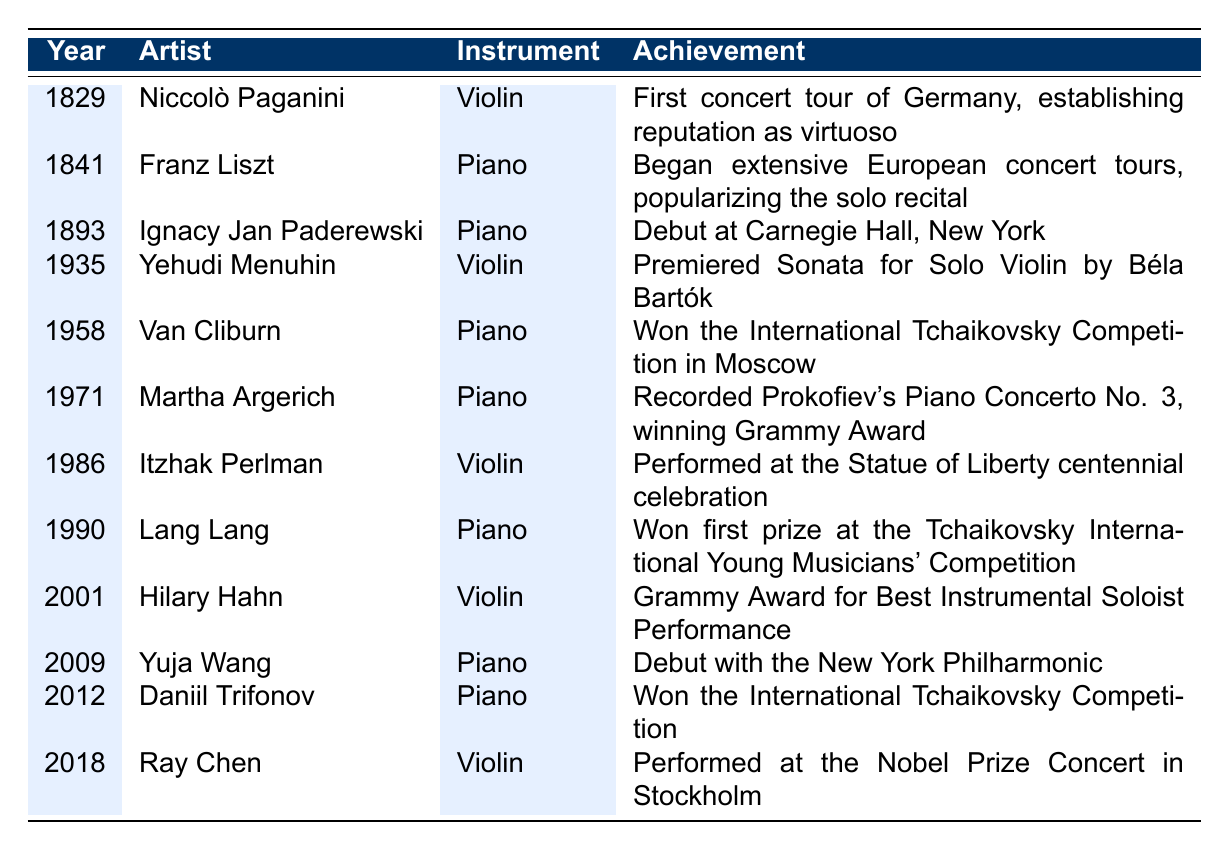What year did Van Cliburn win the International Tchaikovsky Competition? From the table, we can see that Van Cliburn achieved this in the year 1958.
Answer: 1958 Which pianist made his debut at Carnegie Hall in 1893? The table indicates that Ignacy Jan Paderewski made his debut at Carnegie Hall in the year 1893.
Answer: Ignacy Jan Paderewski True or False: Yehudi Menuhin performed a premiere in 1958. The table lists Yehudi Menuhin's notable achievement in 1935, indicating that the statement is false as he did not perform a premiere in 1958.
Answer: False How many violinists are listed in the table? Counting the entries in the table, we find five violinists: Niccolò Paganini, Yehudi Menuhin, Itzhak Perlman, Hilary Hahn, and Ray Chen.
Answer: 5 What is the earliest performance year mentioned in the timeline? The earliest year in the table is 1829, associated with Niccolò Paganini's first concert tour.
Answer: 1829 Which artist recorded Prokofiev's Piano Concerto No. 3? Referring to the table, Martha Argerich is noted for recording this concerto in 1971.
Answer: Martha Argerich Was there a notable performance by a pianist in 2009? The table shows that Yuja Wang made her debut with the New York Philharmonic in 2009, confirming this fact is true.
Answer: Yes What is the difference in years between Van Cliburn's and Lang Lang's notable achievements? Van Cliburn's achievement is in 1958, and Lang Lang's is in 1990. The difference is 1990 - 1958 = 32 years.
Answer: 32 years Which artist won a Grammy Award for Best Instrumental Soloist Performance? The table states that Hilary Hahn won this award in 2001.
Answer: Hilary Hahn If we consider only piano achievements, which artist has the latest notable performance year? According to the table, Daniil Trifonov's achievement in 2012 is the latest among pianists.
Answer: Daniil Trifonov What percentage of the entries are related to violinists? There are 13 total entries and 5 related to violinists. The calculation is (5/13) * 100 ≈ 38.46%.
Answer: Approximately 38.46% How many years separate the performances of Itzhak Perlman and Ray Chen? Itzhak Perlman's performance was in 1986 and Ray Chen's in 2018. The separation is 2018 - 1986 = 32 years.
Answer: 32 years 